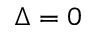<formula> <loc_0><loc_0><loc_500><loc_500>\Delta = 0</formula> 